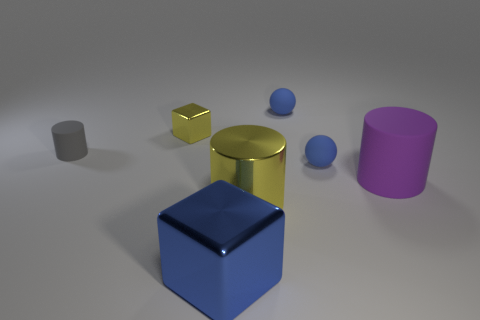What is the shape of the purple matte thing that is the same size as the yellow cylinder?
Make the answer very short. Cylinder. The large cube that is the same material as the small yellow block is what color?
Ensure brevity in your answer.  Blue. There is a big yellow thing; is it the same shape as the blue object that is to the left of the shiny cylinder?
Provide a succinct answer. No. What is the material of the tiny cube that is the same color as the big metal cylinder?
Your response must be concise. Metal. What material is the blue object that is the same size as the purple object?
Ensure brevity in your answer.  Metal. Is there a metal thing of the same color as the big metallic cylinder?
Your response must be concise. Yes. There is a tiny object that is left of the big blue metallic cube and in front of the tiny shiny cube; what is its shape?
Make the answer very short. Cylinder. How many big blue things have the same material as the large block?
Your answer should be compact. 0. Is the number of yellow cylinders right of the big shiny cylinder less than the number of small cylinders behind the gray rubber thing?
Offer a terse response. No. The small blue thing in front of the small rubber thing on the left side of the yellow metal object that is in front of the large purple cylinder is made of what material?
Offer a very short reply. Rubber. 